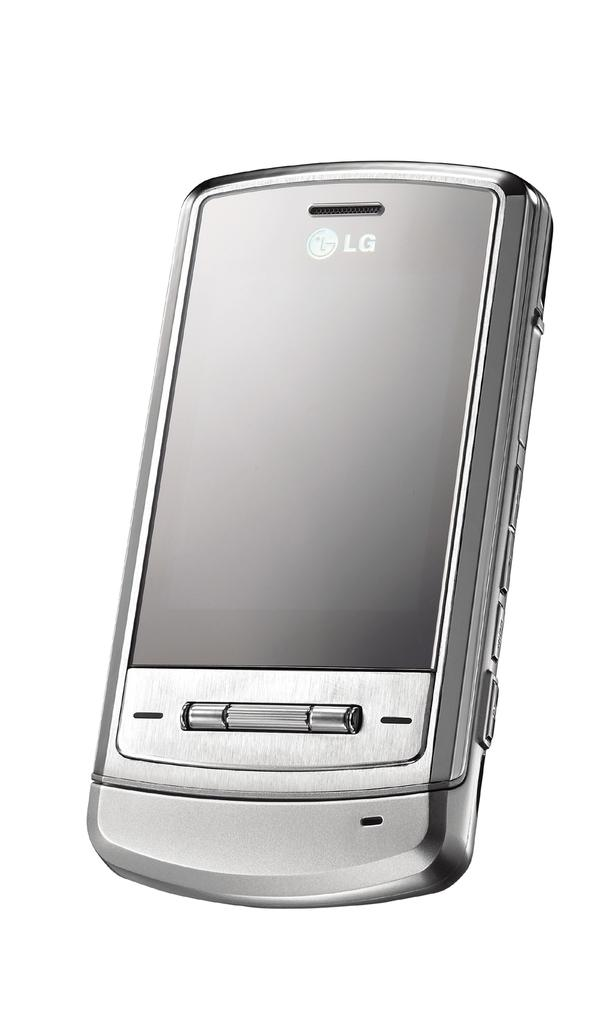<image>
Create a compact narrative representing the image presented. A silver cell phone says LG on the front. 